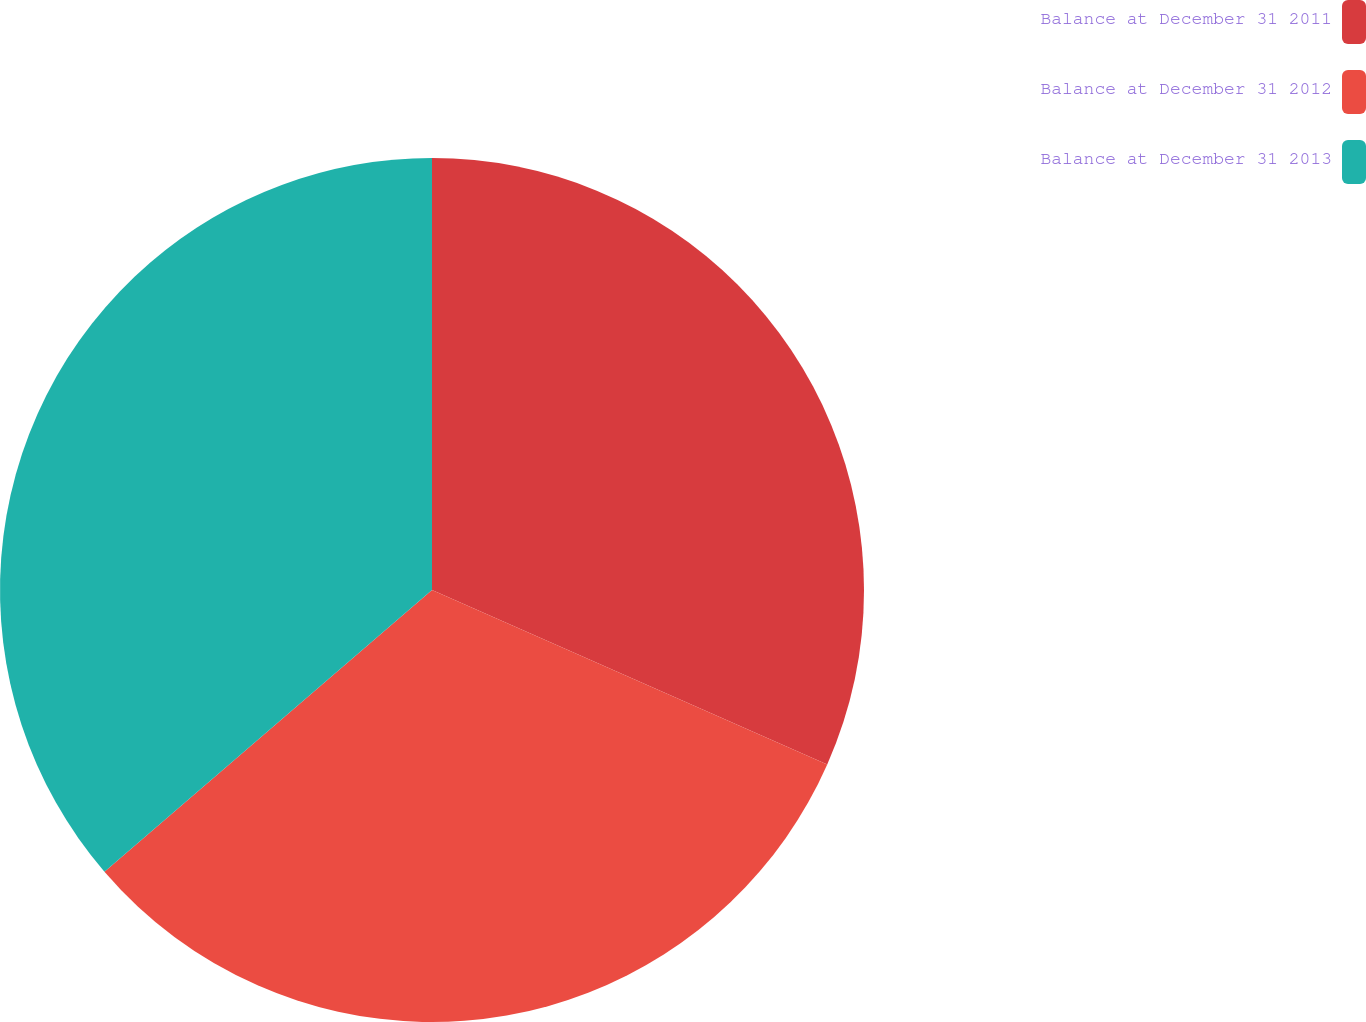Convert chart. <chart><loc_0><loc_0><loc_500><loc_500><pie_chart><fcel>Balance at December 31 2011<fcel>Balance at December 31 2012<fcel>Balance at December 31 2013<nl><fcel>31.61%<fcel>32.08%<fcel>36.3%<nl></chart> 